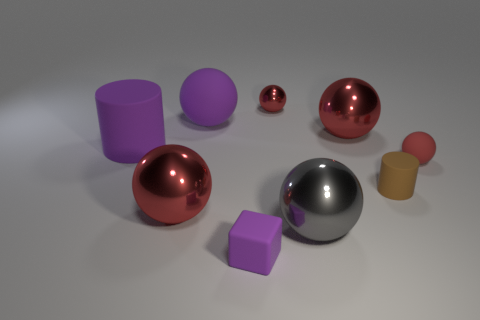Subtract all gray cylinders. How many red balls are left? 4 Subtract 3 spheres. How many spheres are left? 3 Subtract all tiny balls. How many balls are left? 4 Subtract all purple spheres. How many spheres are left? 5 Subtract all cyan balls. Subtract all cyan cylinders. How many balls are left? 6 Subtract all balls. How many objects are left? 3 Subtract 0 brown spheres. How many objects are left? 9 Subtract all large blue balls. Subtract all big purple cylinders. How many objects are left? 8 Add 8 small cubes. How many small cubes are left? 9 Add 1 matte things. How many matte things exist? 6 